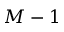Convert formula to latex. <formula><loc_0><loc_0><loc_500><loc_500>M - 1</formula> 